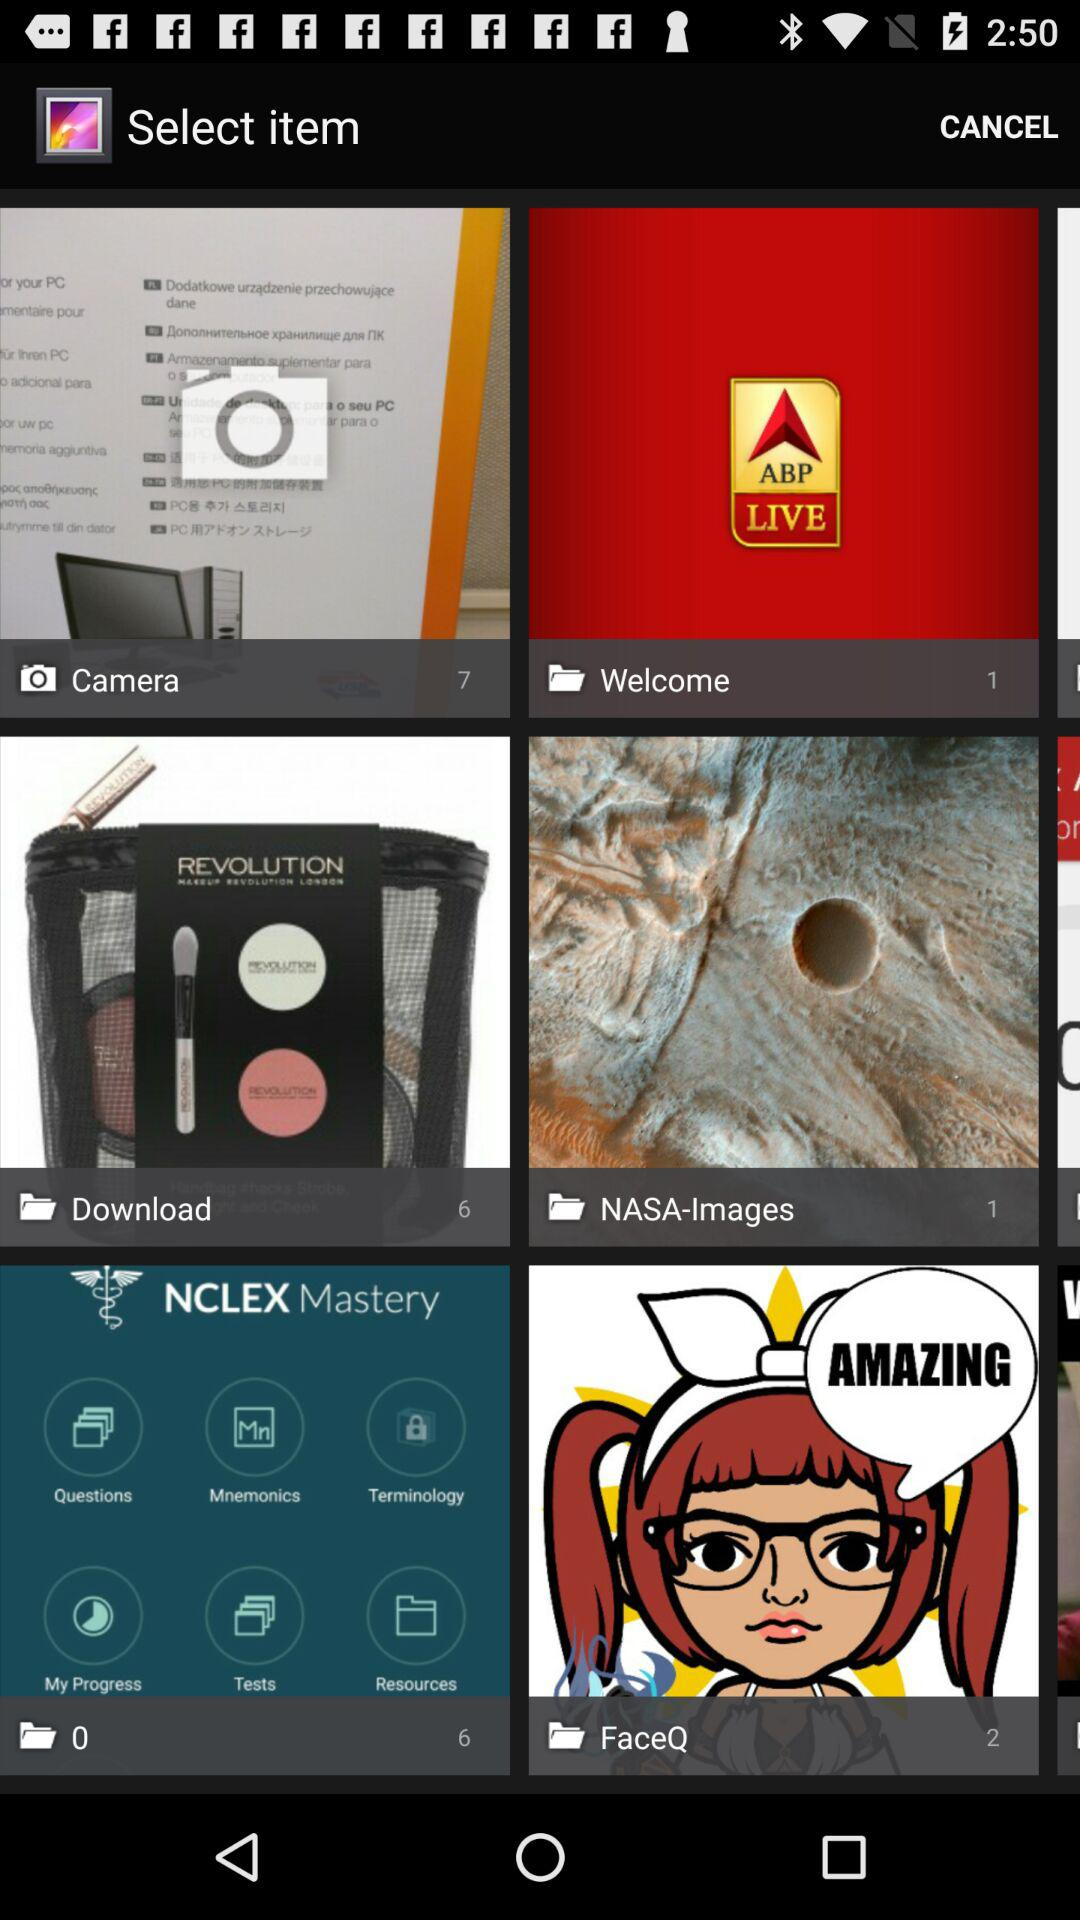How many entities are in the "NASA-Images"? There is 1 entity. 